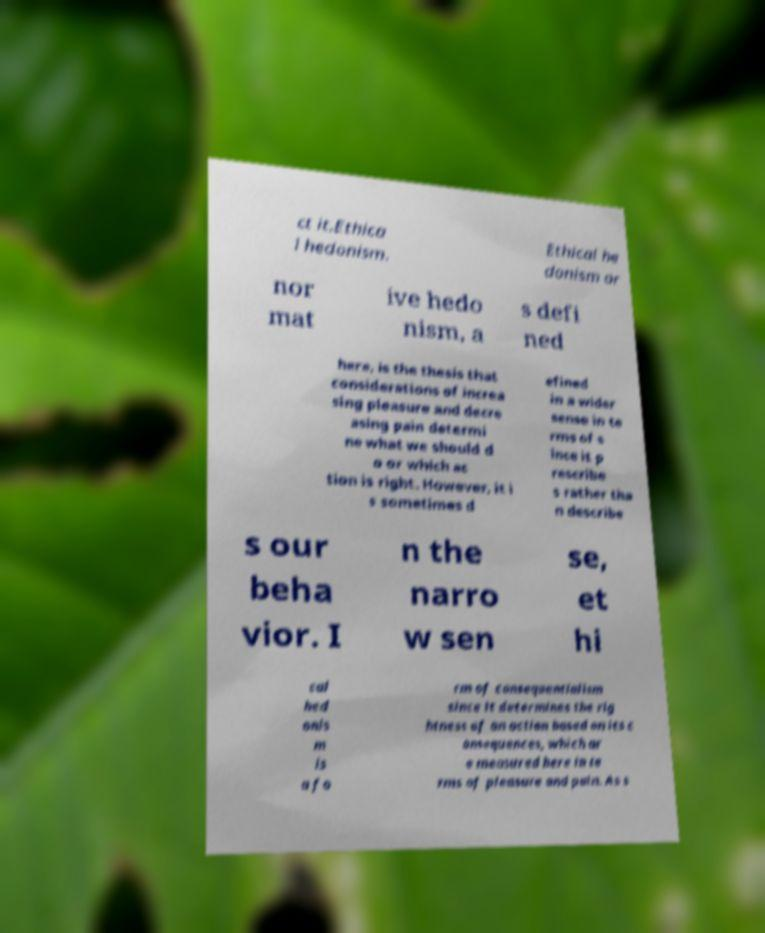Please read and relay the text visible in this image. What does it say? ct it.Ethica l hedonism. Ethical he donism or nor mat ive hedo nism, a s defi ned here, is the thesis that considerations of increa sing pleasure and decre asing pain determi ne what we should d o or which ac tion is right. However, it i s sometimes d efined in a wider sense in te rms of s ince it p rescribe s rather tha n describe s our beha vior. I n the narro w sen se, et hi cal hed onis m is a fo rm of consequentialism since it determines the rig htness of an action based on its c onsequences, which ar e measured here in te rms of pleasure and pain. As s 